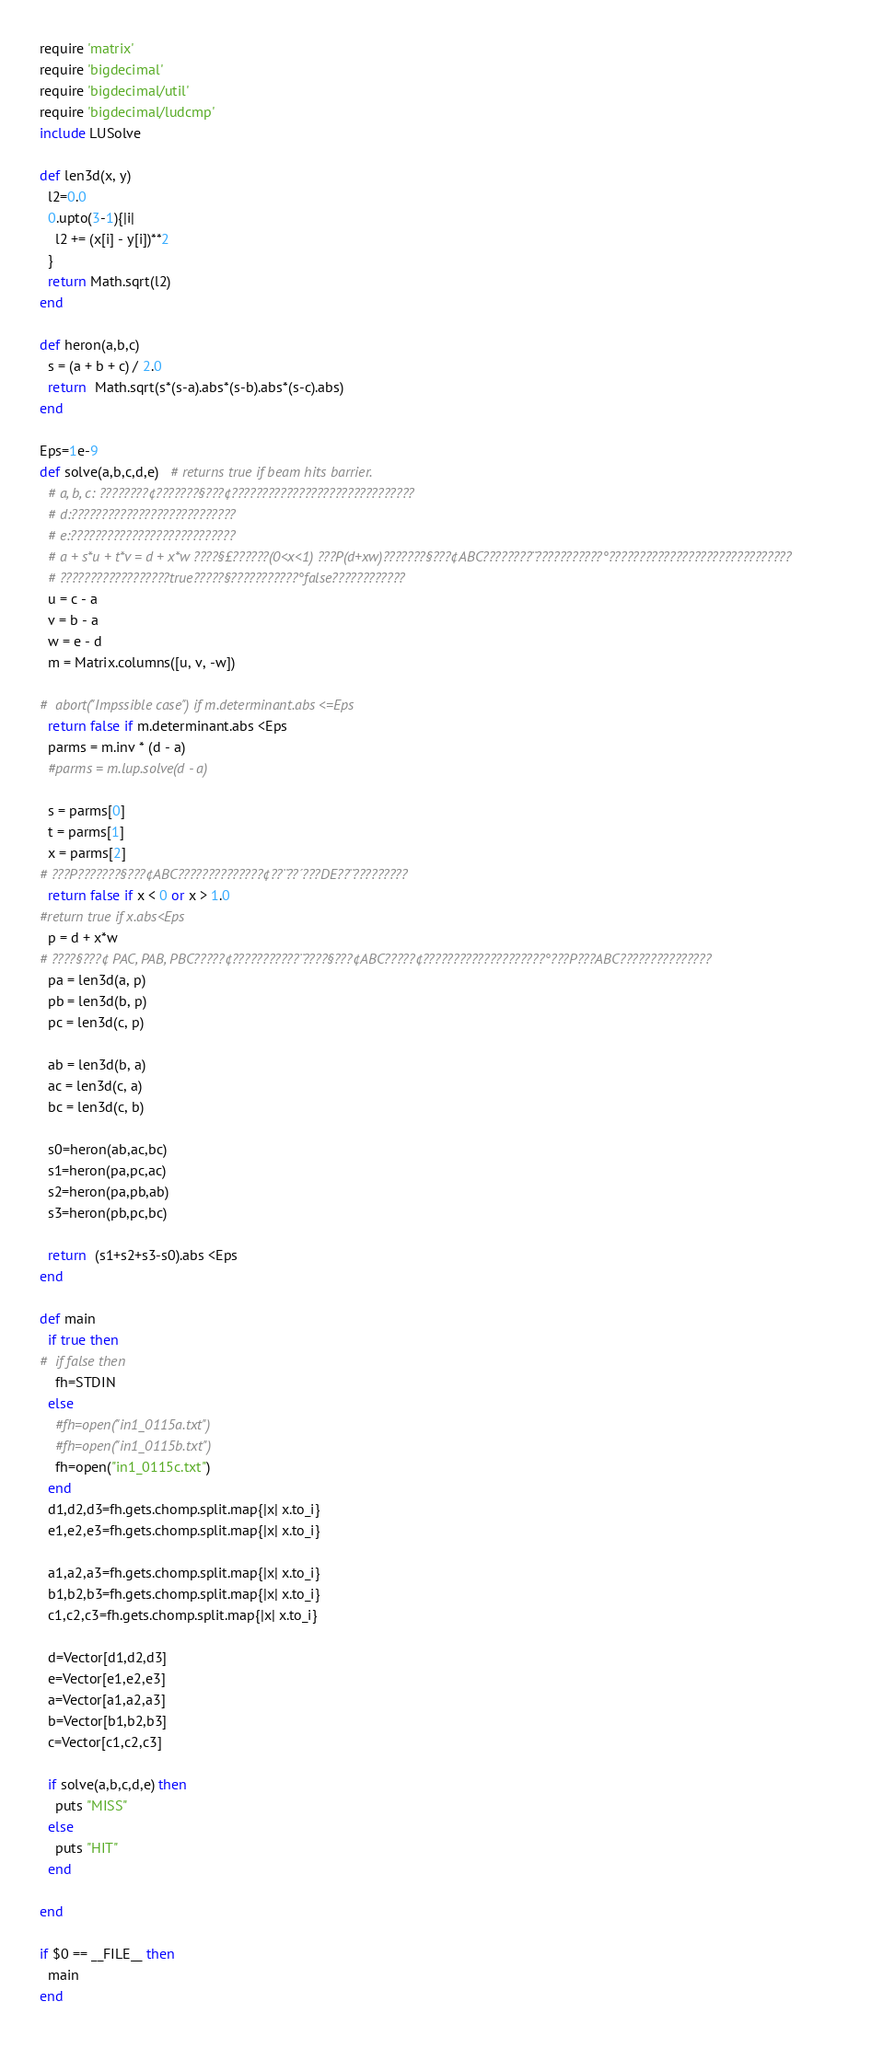Convert code to text. <code><loc_0><loc_0><loc_500><loc_500><_Ruby_>require 'matrix'
require 'bigdecimal'
require 'bigdecimal/util'
require 'bigdecimal/ludcmp'
include LUSolve

def len3d(x, y)
  l2=0.0
  0.upto(3-1){|i|
    l2 += (x[i] - y[i])**2
  }
  return Math.sqrt(l2)
end

def heron(a,b,c)
  s = (a + b + c) / 2.0
  return  Math.sqrt(s*(s-a).abs*(s-b).abs*(s-c).abs)
end

Eps=1e-9
def solve(a,b,c,d,e)   # returns true if beam hits barrier.
  # a, b, c: ????????¢???????§???¢??????????????????????????????
  # d:???????????????????????????
  # e:???????????????????????????
  # a + s*u + t*v = d + x*w ????§£??????(0<x<1) ???P(d+xw)???????§???¢ABC????????¨???????????°??????????????????????????????
  # ??????????????????true?????§???????????°false????????????
  u = c - a
  v = b - a
  w = e - d
  m = Matrix.columns([u, v, -w])

#  abort("Impssible case") if m.determinant.abs <=Eps
  return false if m.determinant.abs <Eps
  parms = m.inv * (d - a)
  #parms = m.lup.solve(d - a)

  s = parms[0]
  t = parms[1]
  x = parms[2]
# ???P???????§???¢ABC??????????????¢??¨??´???DE??¨?????????
  return false if x < 0 or x > 1.0
#return true if x.abs<Eps
  p = d + x*w
# ????§???¢ PAC, PAB, PBC?????¢???????????¨????§???¢ABC?????¢????????????????????°???P???ABC???????????????
  pa = len3d(a, p)
  pb = len3d(b, p)
  pc = len3d(c, p)

  ab = len3d(b, a)
  ac = len3d(c, a)
  bc = len3d(c, b)

  s0=heron(ab,ac,bc)
  s1=heron(pa,pc,ac)
  s2=heron(pa,pb,ab)
  s3=heron(pb,pc,bc)

  return  (s1+s2+s3-s0).abs <Eps
end

def main
  if true then
#  if false then
    fh=STDIN
  else
    #fh=open("in1_0115a.txt")
    #fh=open("in1_0115b.txt")
    fh=open("in1_0115c.txt")
  end
  d1,d2,d3=fh.gets.chomp.split.map{|x| x.to_i}
  e1,e2,e3=fh.gets.chomp.split.map{|x| x.to_i}

  a1,a2,a3=fh.gets.chomp.split.map{|x| x.to_i}
  b1,b2,b3=fh.gets.chomp.split.map{|x| x.to_i}
  c1,c2,c3=fh.gets.chomp.split.map{|x| x.to_i}

  d=Vector[d1,d2,d3]
  e=Vector[e1,e2,e3]
  a=Vector[a1,a2,a3]
  b=Vector[b1,b2,b3]
  c=Vector[c1,c2,c3]

  if solve(a,b,c,d,e) then
    puts "MISS"
  else
    puts "HIT"
  end

end

if $0 == __FILE__ then
  main
end</code> 